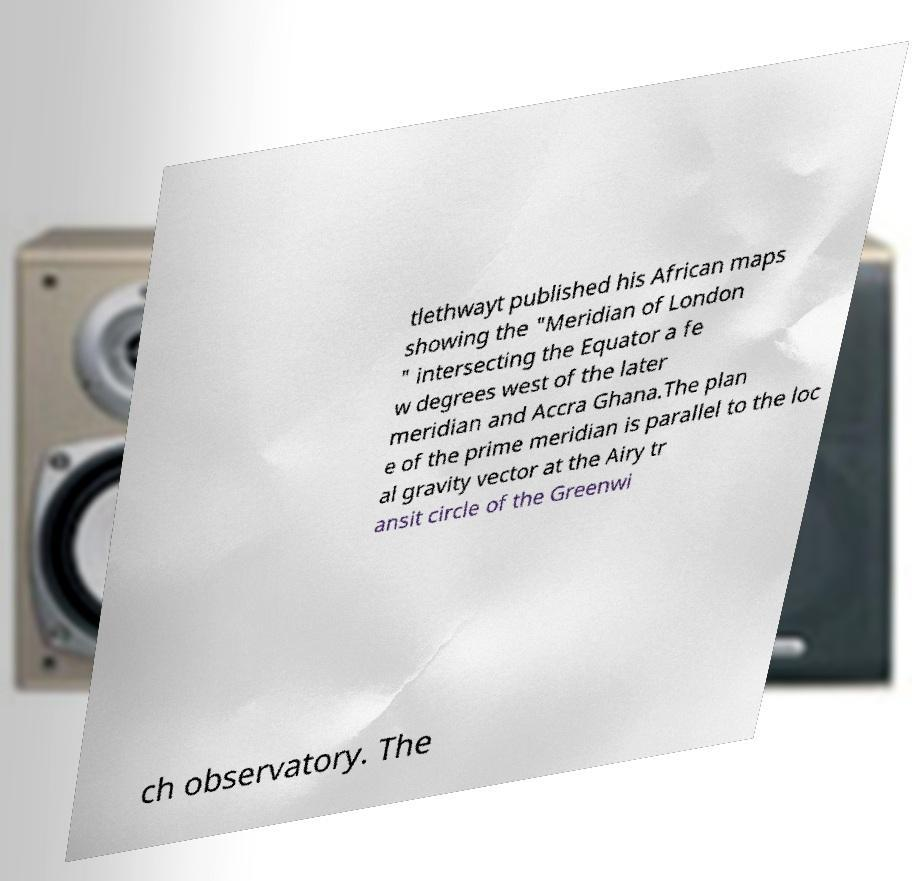There's text embedded in this image that I need extracted. Can you transcribe it verbatim? tlethwayt published his African maps showing the "Meridian of London " intersecting the Equator a fe w degrees west of the later meridian and Accra Ghana.The plan e of the prime meridian is parallel to the loc al gravity vector at the Airy tr ansit circle of the Greenwi ch observatory. The 